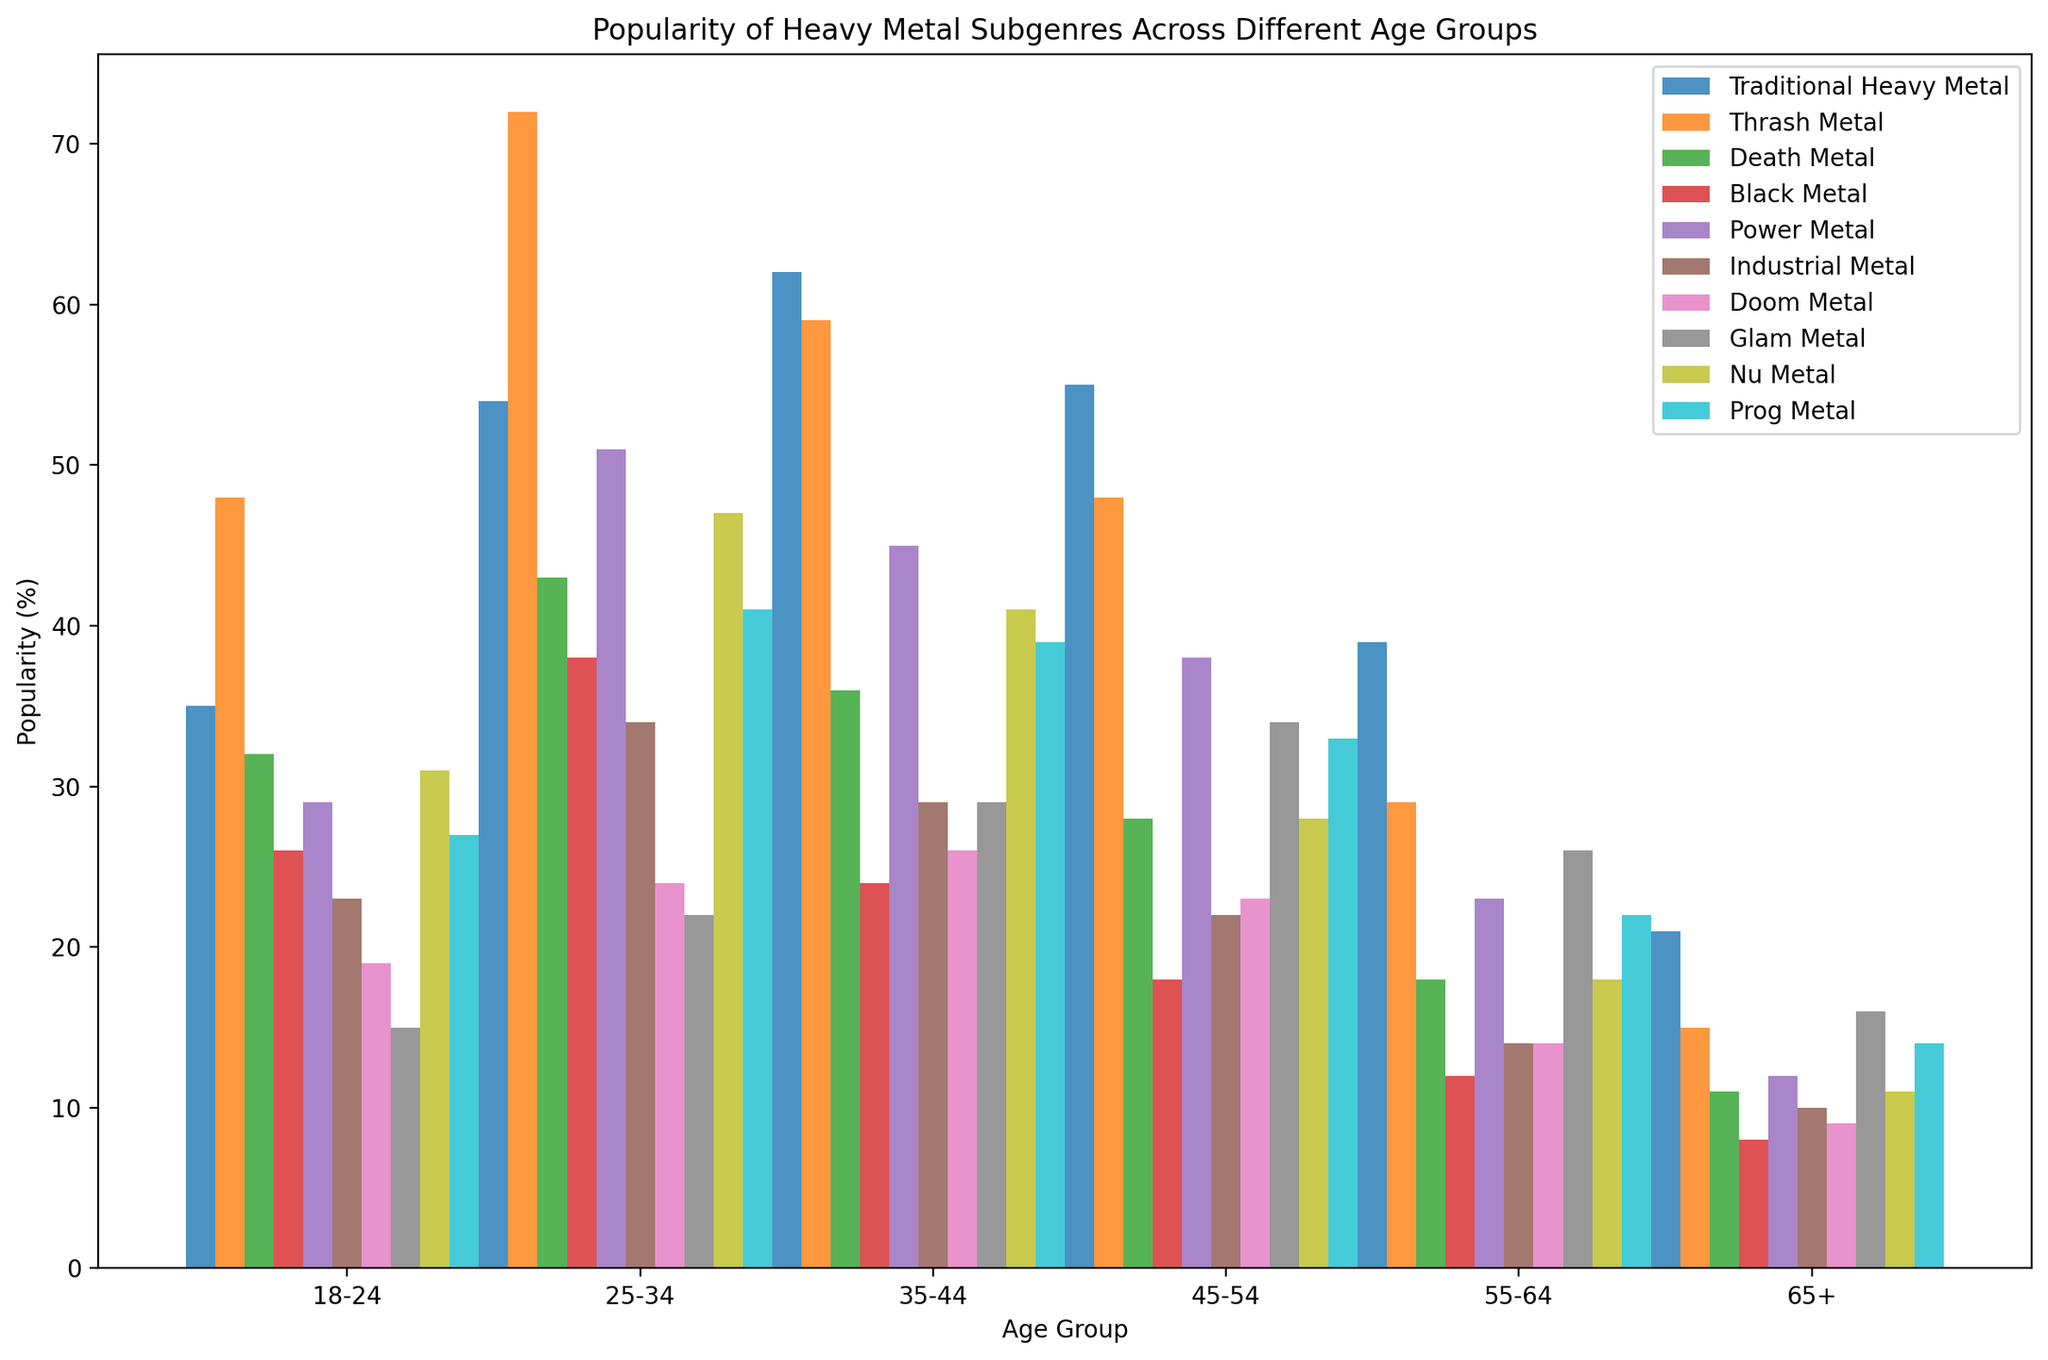What's the most popular heavy metal subgenre among the 25-34 age group? To determine the most popular subgenre among the 25-34 age group, look at the heights of the bars for this group. The tallest bar represents Thrash Metal, which has a value of 72%.
Answer: Thrash Metal Which age group shows the highest popularity for Traditional Heavy Metal? To identify the age group with the highest popularity for Traditional Heavy Metal, compare the heights of the bars for Traditional Heavy Metal across all age groups. The 35-44 age group has the highest bar with a value of 62%.
Answer: 35-44 How much more popular is Death Metal in the 25-34 age group compared to the 55-64 age group? First, find the value of Death Metal for the 25-34 age group, which is 43%. Then find the value for the 55-64 age group, which is 18%. The difference is 43 - 18 = 25%.
Answer: 25% Which heavy metal subgenres see a decline in popularity as age increases from 18-24 to 65+? For each subgenre, compare the values starting from the 18-24 age group to the 65+ age group. A decline can be seen in Traditional Heavy Metal (35 to 21), Thrash Metal (48 to 15), Death Metal (32 to 11), Black Metal (26 to 8), Power Metal (29 to 12), Industrial Metal (23 to 10), Doom Metal (19 to 9), and Nu Metal (31 to 11).
Answer: Traditional Heavy Metal, Thrash Metal, Death Metal, Black Metal, Power Metal, Industrial Metal, Doom Metal, Nu Metal What is the average popularity of Prog Metal across all age groups? To find the average, sum the values of Prog Metal across all age groups: 27 + 41 + 39 + 33 + 22 + 14 = 176. Then, divide by the number of age groups, which is 6. The average is 176 / 6 ≈ 29.33%.
Answer: 29.33% Which heavy metal subgenre has the least popularity in the 45-54 age group? Inspect the bars for the 45-54 age group and find the shortest one. The shortest bar represents Black Metal with a value of 18%.
Answer: Black Metal How does the popularity of Glam Metal change from the 35-44 age group to the 45-54 age group? Compare the values for Glam Metal in the 35-44 age group (29%) to the 45-54 age group (34%). There is an increase in popularity by 5%.
Answer: Increases by 5% Is Doom Metal more popular among the 55-64 age group or the 65+ age group? Compare the values for Doom Metal in the 55-64 age group (14%) and the 65+ age group (9%). Doom Metal is more popular in the 55-64 age group.
Answer: 55-64 What is the combined popularity of Thrash Metal and Death Metal for the age group 18-24? Add the values of Thrash Metal (48%) and Death Metal (32%) for the 18-24 age group: 48 + 32 = 80%.
Answer: 80% Which age group has the closest popularity percentages between Traditional Heavy Metal and Power Metal? Compare the difference between Traditional Heavy Metal and Power Metal across all age groups: 18-24 (35-29=6), 25-34 (54-51=3), 35-44 (62-45=17), 45-54 (55-38=17), 55-64 (39-23=16), 65+ (21-12=9). The 25-34 age group has the closest percentage, difference of 3%.
Answer: 25-34 